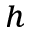<formula> <loc_0><loc_0><loc_500><loc_500>^ { h }</formula> 